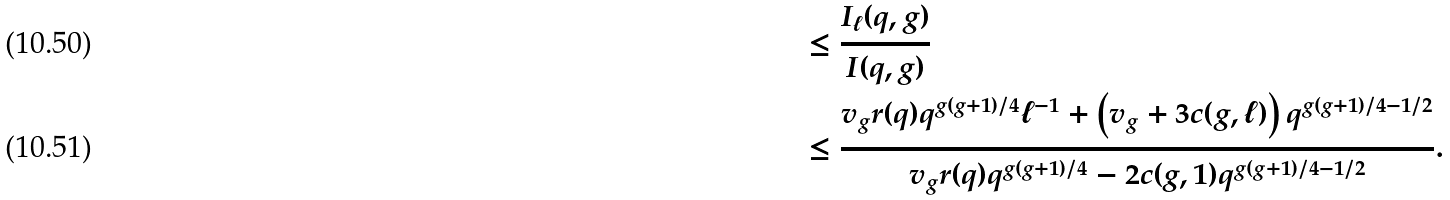Convert formula to latex. <formula><loc_0><loc_0><loc_500><loc_500>& \leq \frac { I _ { \ell } ( q , g ) } { I ( q , g ) } \\ & \leq \frac { v _ { g } r ( q ) q ^ { g ( g + 1 ) / 4 } \ell ^ { - 1 } + \left ( v _ { g } + 3 c ( g , \ell ) \right ) q ^ { g ( g + 1 ) / 4 - 1 / 2 } } { v _ { g } r ( q ) q ^ { g ( g + 1 ) / 4 } - 2 c ( g , 1 ) q ^ { g ( g + 1 ) / 4 - 1 / 2 } } .</formula> 